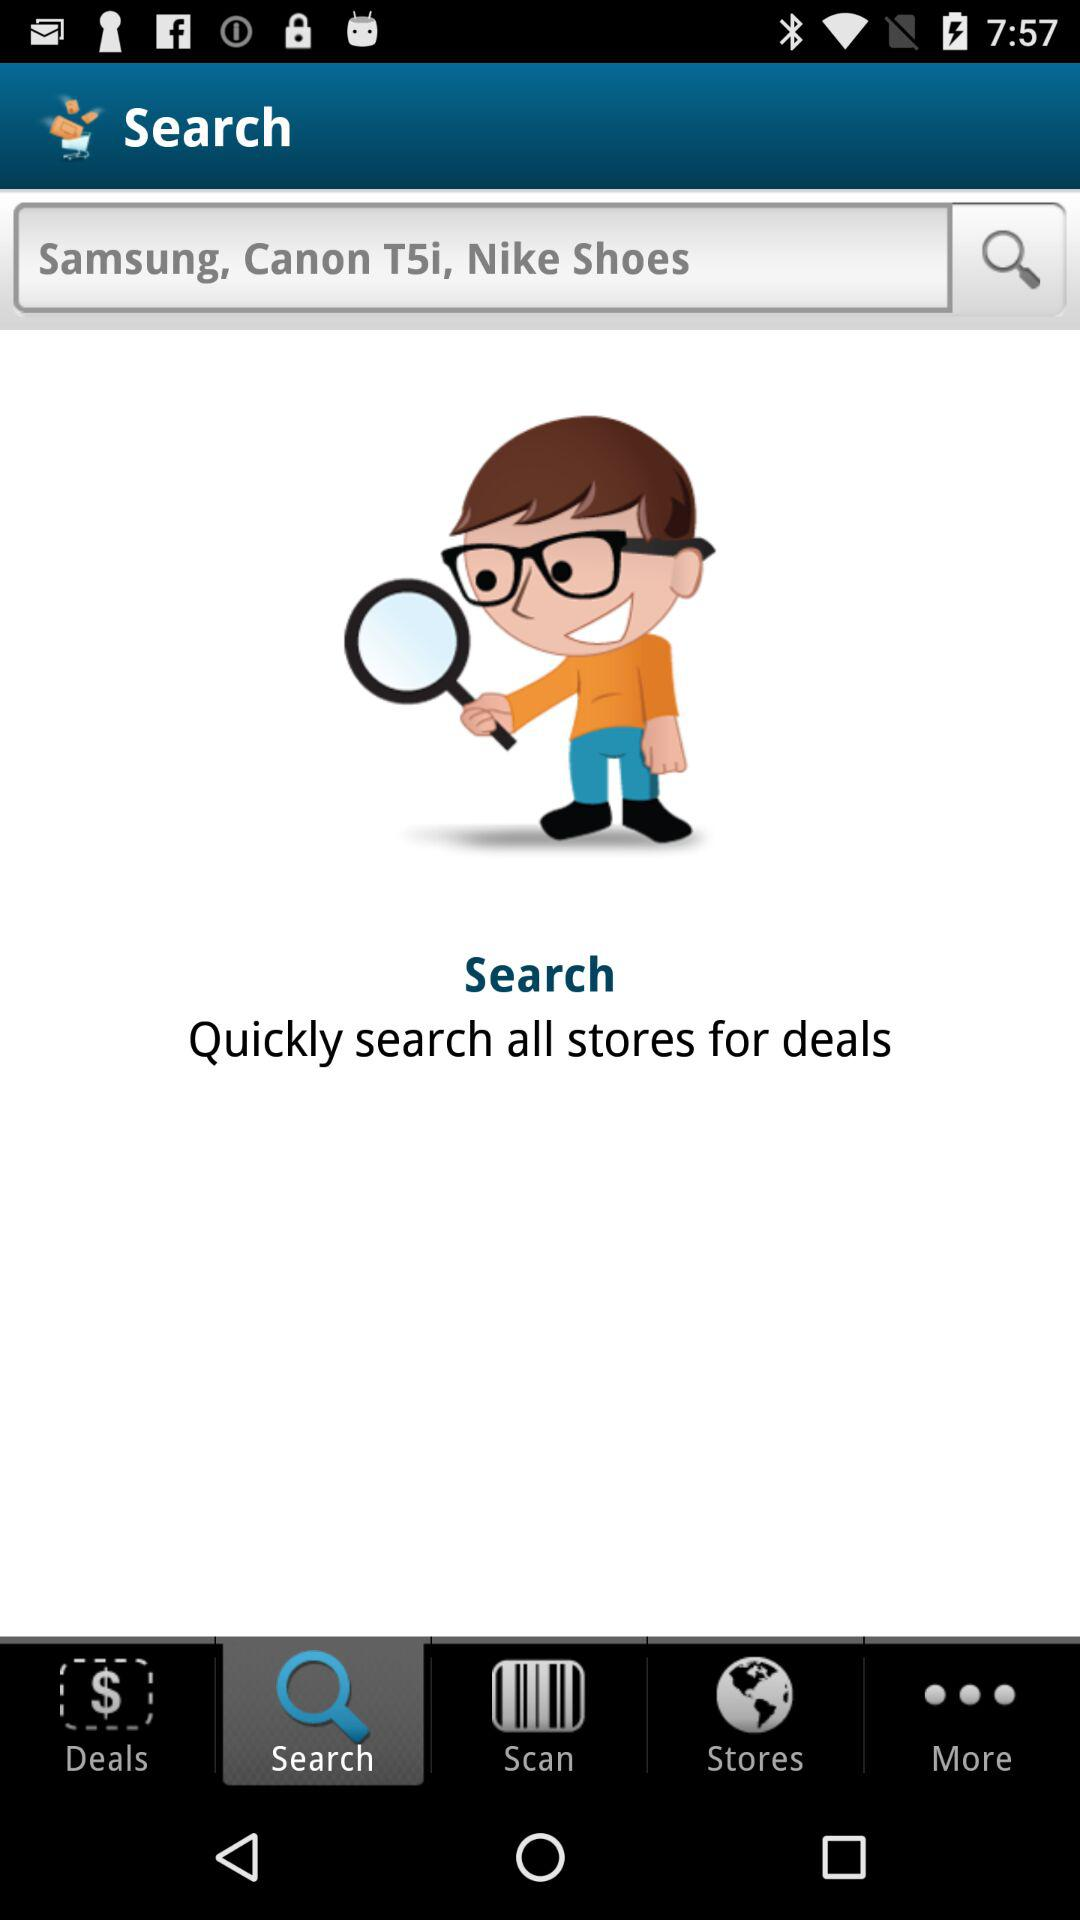What is the input in the search bar? The input in the search bar is "Samsung, Canon T5i, Nike Shoes". 